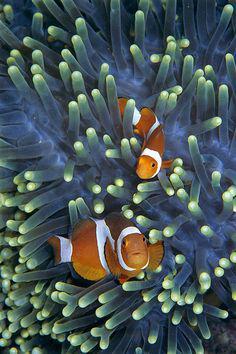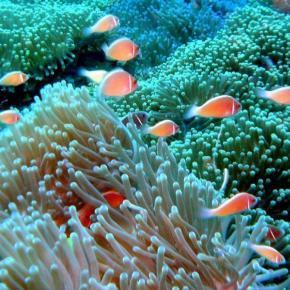The first image is the image on the left, the second image is the image on the right. Analyze the images presented: Is the assertion "The left image contains exactly two fish, which are orange with at least one white stripe, swimming face-forward in anemone tendrils." valid? Answer yes or no. Yes. The first image is the image on the left, the second image is the image on the right. Given the left and right images, does the statement "The left and right image contains the same number of striped fish faces." hold true? Answer yes or no. No. 